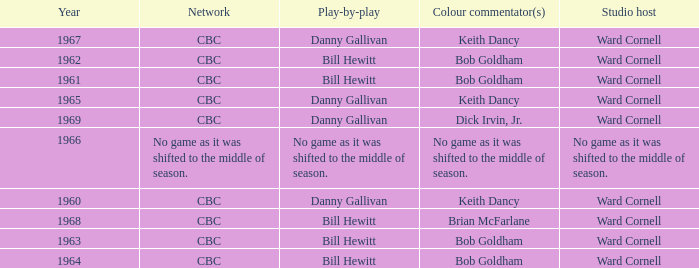Who gave the play by play commentary with studio host Ward Cornell? Danny Gallivan, Bill Hewitt, Danny Gallivan, Danny Gallivan, Bill Hewitt, Bill Hewitt, Bill Hewitt, Bill Hewitt, Danny Gallivan. 